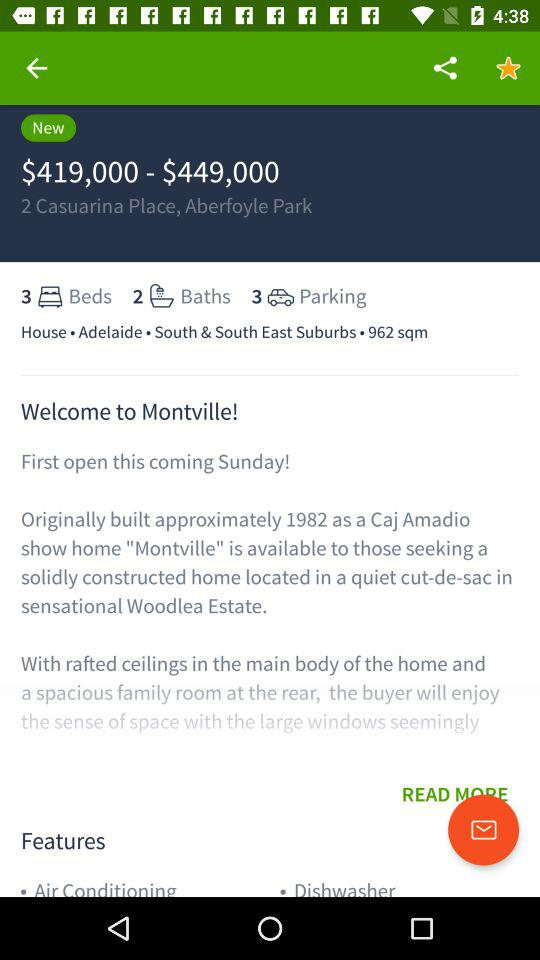What is the price range of 2 Casuarina Place, Aberfoyle Park? The price ranges from $419,000 to $449,000. 